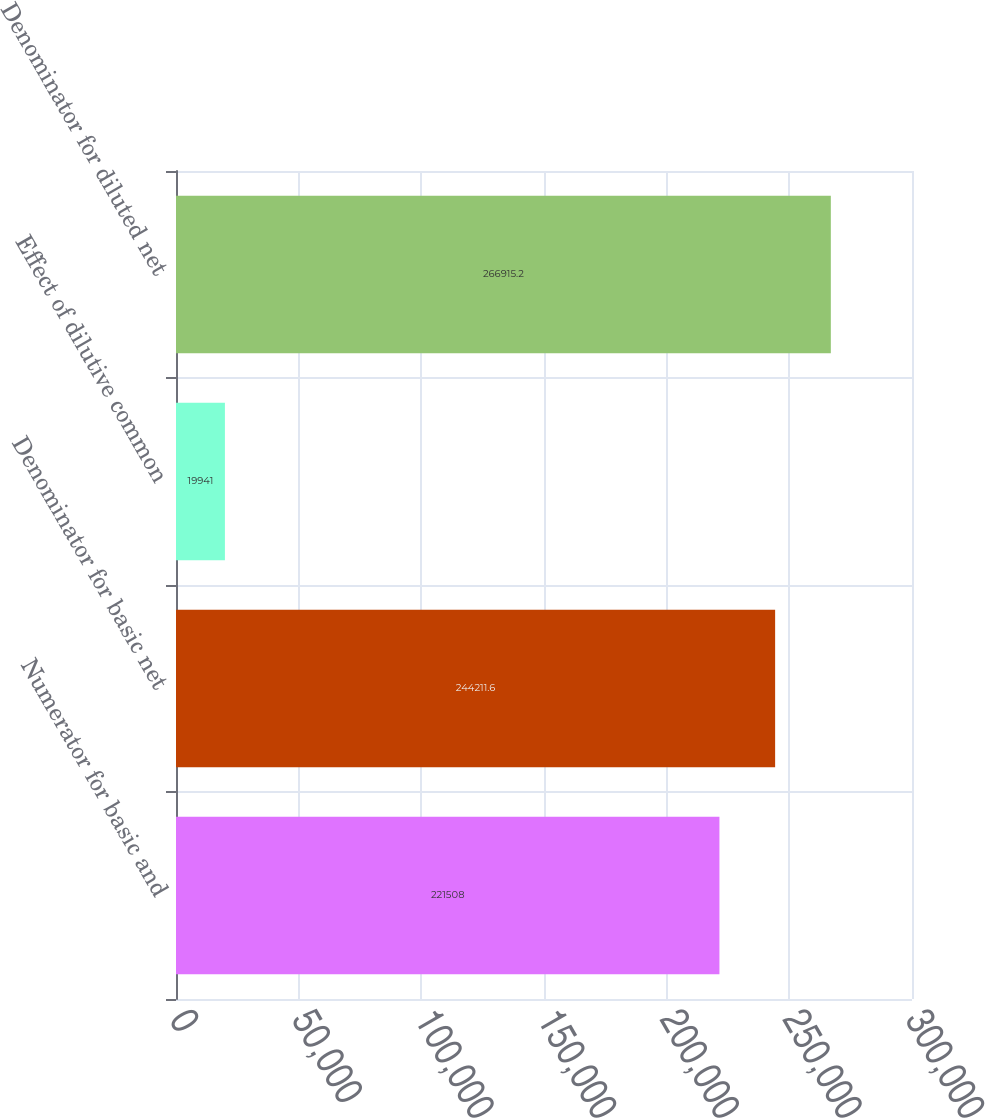Convert chart. <chart><loc_0><loc_0><loc_500><loc_500><bar_chart><fcel>Numerator for basic and<fcel>Denominator for basic net<fcel>Effect of dilutive common<fcel>Denominator for diluted net<nl><fcel>221508<fcel>244212<fcel>19941<fcel>266915<nl></chart> 